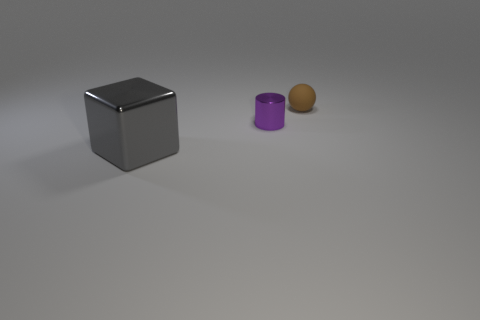Add 3 blue matte balls. How many objects exist? 6 Subtract all spheres. How many objects are left? 2 Subtract all small gray shiny things. Subtract all shiny blocks. How many objects are left? 2 Add 3 tiny purple shiny things. How many tiny purple shiny things are left? 4 Add 2 cylinders. How many cylinders exist? 3 Subtract 0 yellow cubes. How many objects are left? 3 